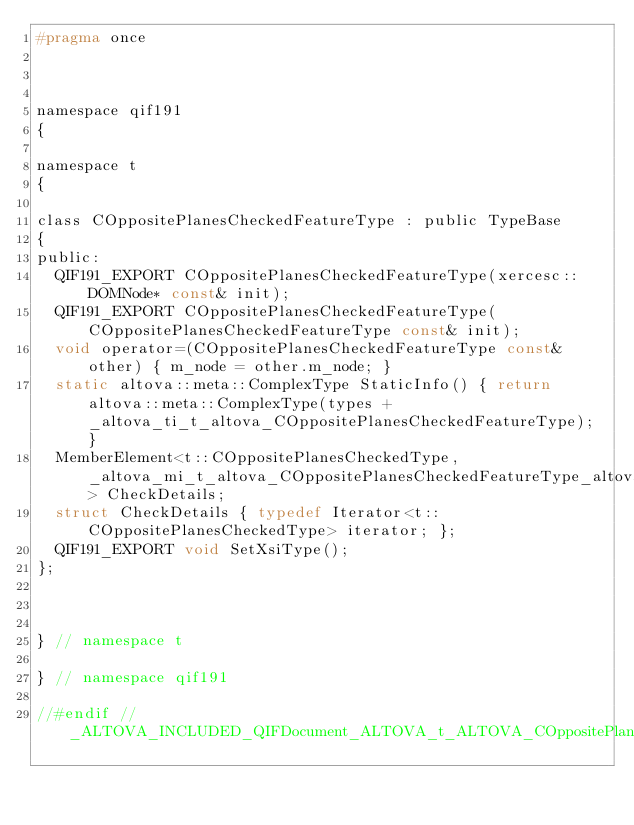Convert code to text. <code><loc_0><loc_0><loc_500><loc_500><_C_>#pragma once



namespace qif191
{

namespace t
{	

class COppositePlanesCheckedFeatureType : public TypeBase
{
public:
	QIF191_EXPORT COppositePlanesCheckedFeatureType(xercesc::DOMNode* const& init);
	QIF191_EXPORT COppositePlanesCheckedFeatureType(COppositePlanesCheckedFeatureType const& init);
	void operator=(COppositePlanesCheckedFeatureType const& other) { m_node = other.m_node; }
	static altova::meta::ComplexType StaticInfo() { return altova::meta::ComplexType(types + _altova_ti_t_altova_COppositePlanesCheckedFeatureType); }
	MemberElement<t::COppositePlanesCheckedType, _altova_mi_t_altova_COppositePlanesCheckedFeatureType_altova_CheckDetails> CheckDetails;
	struct CheckDetails { typedef Iterator<t::COppositePlanesCheckedType> iterator; };
	QIF191_EXPORT void SetXsiType();
};



} // namespace t

}	// namespace qif191

//#endif // _ALTOVA_INCLUDED_QIFDocument_ALTOVA_t_ALTOVA_COppositePlanesCheckedFeatureType
</code> 